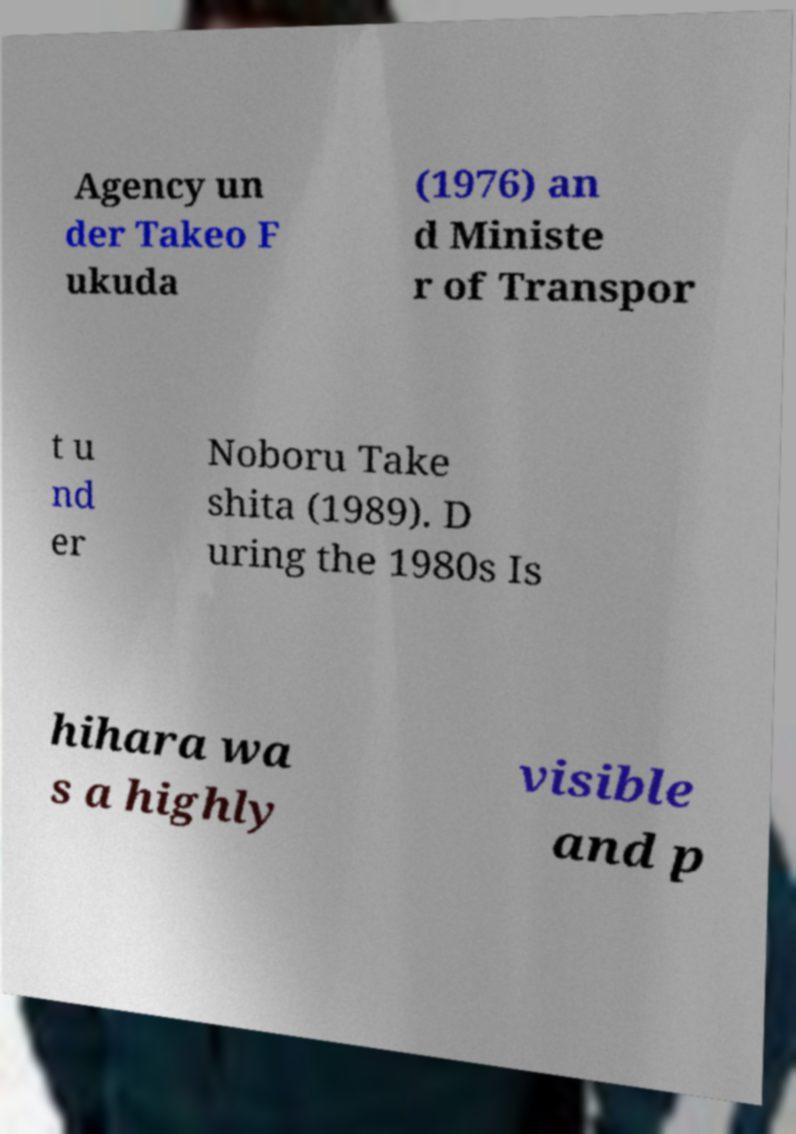Can you accurately transcribe the text from the provided image for me? Agency un der Takeo F ukuda (1976) an d Ministe r of Transpor t u nd er Noboru Take shita (1989). D uring the 1980s Is hihara wa s a highly visible and p 